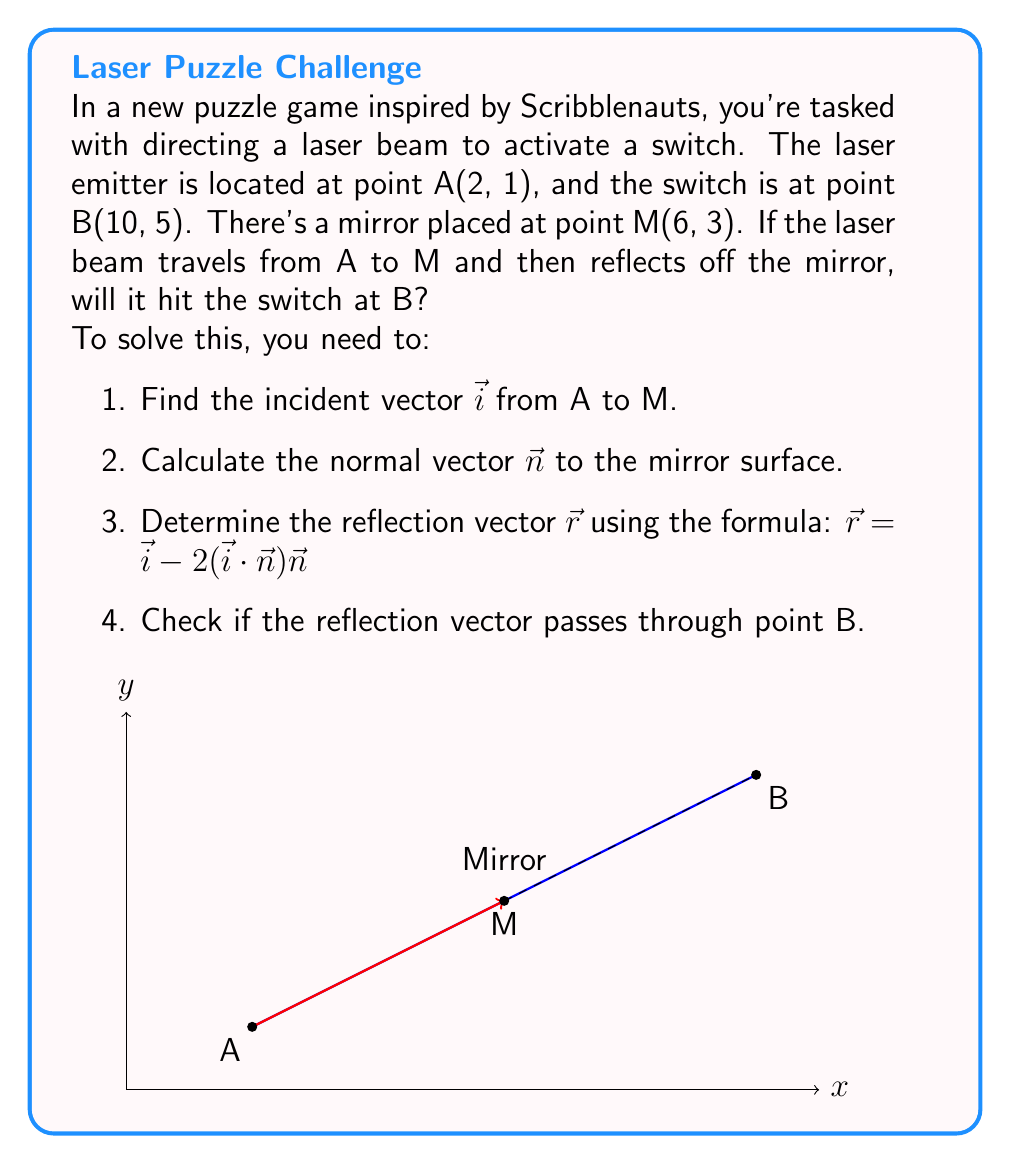What is the answer to this math problem? Let's solve this step-by-step:

1. Find the incident vector $\vec{i}$ from A to M:
   $\vec{i} = M - A = (6-2, 3-1) = (4, 2)$

2. To find the normal vector $\vec{n}$, we need a vector perpendicular to the mirror surface. 
   Let's assume the mirror is perpendicular to the line AM. Then $\vec{n} = (-2, 4)$.
   Normalize $\vec{n}$: $\vec{n} = \frac{(-2, 4)}{\sqrt{(-2)^2 + 4^2}} = \frac{(-1, 2)}{\sqrt{5}}$

3. Calculate the reflection vector $\vec{r}$:
   $\vec{r} = \vec{i} - 2(\vec{i} \cdot \vec{n})\vec{n}$
   
   First, calculate $\vec{i} \cdot \vec{n}$:
   $\vec{i} \cdot \vec{n} = (4, 2) \cdot \frac{(-1, 2)}{\sqrt{5}} = \frac{-4 + 4}{\sqrt{5}} = 0$
   
   Now, $\vec{r} = (4, 2) - 2(0)\frac{(-1, 2)}{\sqrt{5}} = (4, 2)$

4. Check if the reflection vector passes through point B:
   The line equation from M in the direction of $\vec{r}$ is:
   $(x, y) = (6, 3) + t(4, 2)$, where $t$ is a scalar.

   For this line to pass through B(10, 5), there must exist a $t$ such that:
   $10 = 6 + 4t$ and $5 = 3 + 2t$

   Solving either equation gives $t = 1$.
   
   Substituting $t = 1$ into the other equation confirms that the line passes through B.

Therefore, the laser beam will indeed hit the switch at B after reflecting off the mirror at M.
Answer: Yes, the laser beam will hit the switch. 